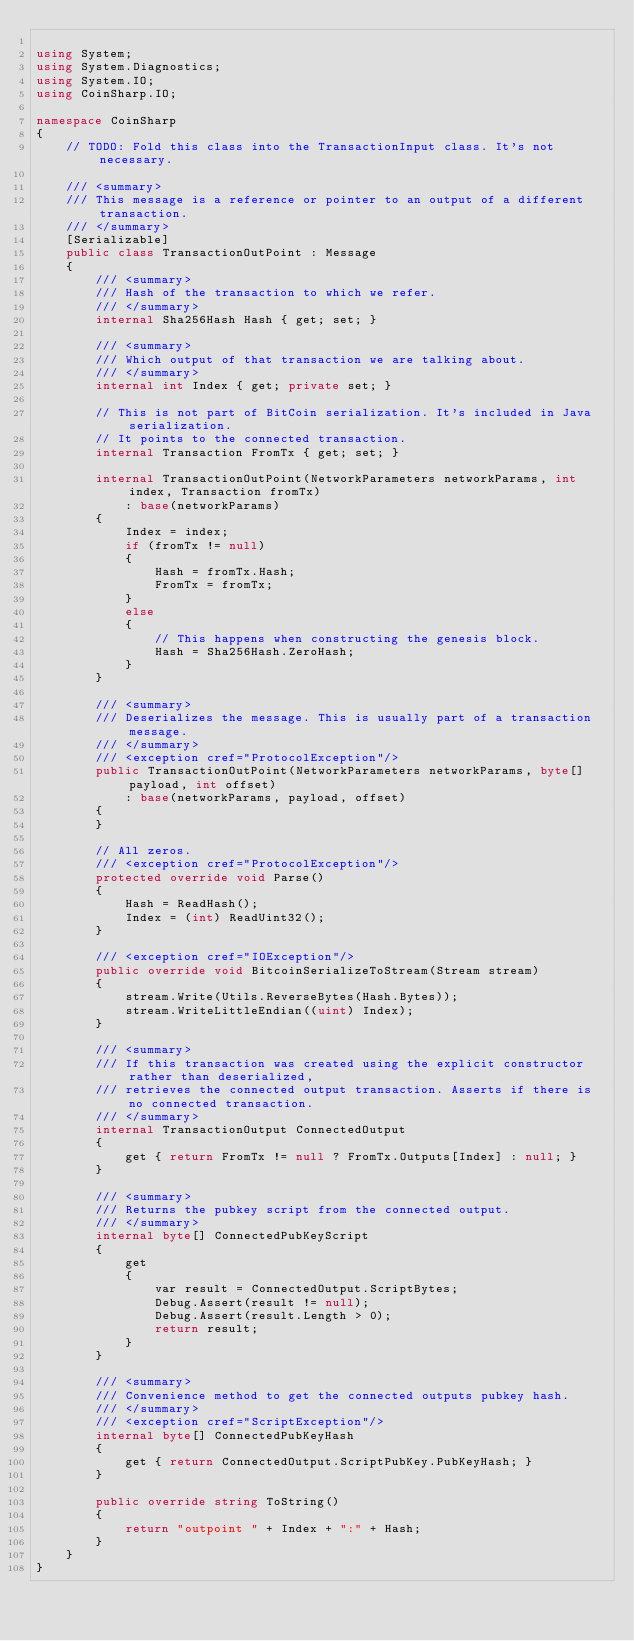<code> <loc_0><loc_0><loc_500><loc_500><_C#_>
using System;
using System.Diagnostics;
using System.IO;
using CoinSharp.IO;

namespace CoinSharp
{
    // TODO: Fold this class into the TransactionInput class. It's not necessary.

    /// <summary>
    /// This message is a reference or pointer to an output of a different transaction.
    /// </summary>
    [Serializable]
    public class TransactionOutPoint : Message
    {
        /// <summary>
        /// Hash of the transaction to which we refer.
        /// </summary>
        internal Sha256Hash Hash { get; set; }

        /// <summary>
        /// Which output of that transaction we are talking about.
        /// </summary>
        internal int Index { get; private set; }

        // This is not part of BitCoin serialization. It's included in Java serialization.
        // It points to the connected transaction.
        internal Transaction FromTx { get; set; }

        internal TransactionOutPoint(NetworkParameters networkParams, int index, Transaction fromTx)
            : base(networkParams)
        {
            Index = index;
            if (fromTx != null)
            {
                Hash = fromTx.Hash;
                FromTx = fromTx;
            }
            else
            {
                // This happens when constructing the genesis block.
                Hash = Sha256Hash.ZeroHash;
            }
        }

        /// <summary>
        /// Deserializes the message. This is usually part of a transaction message.
        /// </summary>
        /// <exception cref="ProtocolException"/>
        public TransactionOutPoint(NetworkParameters networkParams, byte[] payload, int offset)
            : base(networkParams, payload, offset)
        {
        }

        // All zeros.
        /// <exception cref="ProtocolException"/>
        protected override void Parse()
        {
            Hash = ReadHash();
            Index = (int) ReadUint32();
        }

        /// <exception cref="IOException"/>
        public override void BitcoinSerializeToStream(Stream stream)
        {
            stream.Write(Utils.ReverseBytes(Hash.Bytes));
            stream.WriteLittleEndian((uint) Index);
        }

        /// <summary>
        /// If this transaction was created using the explicit constructor rather than deserialized,
        /// retrieves the connected output transaction. Asserts if there is no connected transaction.
        /// </summary>
        internal TransactionOutput ConnectedOutput
        {
            get { return FromTx != null ? FromTx.Outputs[Index] : null; }
        }

        /// <summary>
        /// Returns the pubkey script from the connected output.
        /// </summary>
        internal byte[] ConnectedPubKeyScript
        {
            get
            {
                var result = ConnectedOutput.ScriptBytes;
                Debug.Assert(result != null);
                Debug.Assert(result.Length > 0);
                return result;
            }
        }

        /// <summary>
        /// Convenience method to get the connected outputs pubkey hash.
        /// </summary>
        /// <exception cref="ScriptException"/>
        internal byte[] ConnectedPubKeyHash
        {
            get { return ConnectedOutput.ScriptPubKey.PubKeyHash; }
        }

        public override string ToString()
        {
            return "outpoint " + Index + ":" + Hash;
        }
    }
}</code> 